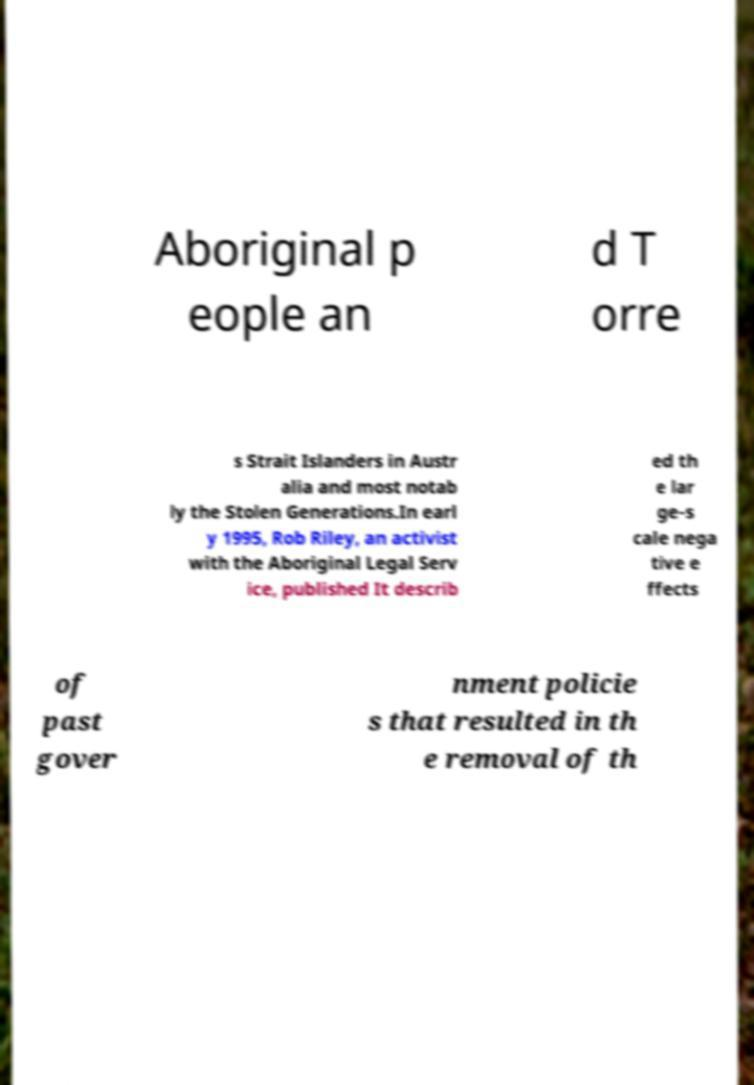Could you assist in decoding the text presented in this image and type it out clearly? Aboriginal p eople an d T orre s Strait Islanders in Austr alia and most notab ly the Stolen Generations.In earl y 1995, Rob Riley, an activist with the Aboriginal Legal Serv ice, published It describ ed th e lar ge-s cale nega tive e ffects of past gover nment policie s that resulted in th e removal of th 